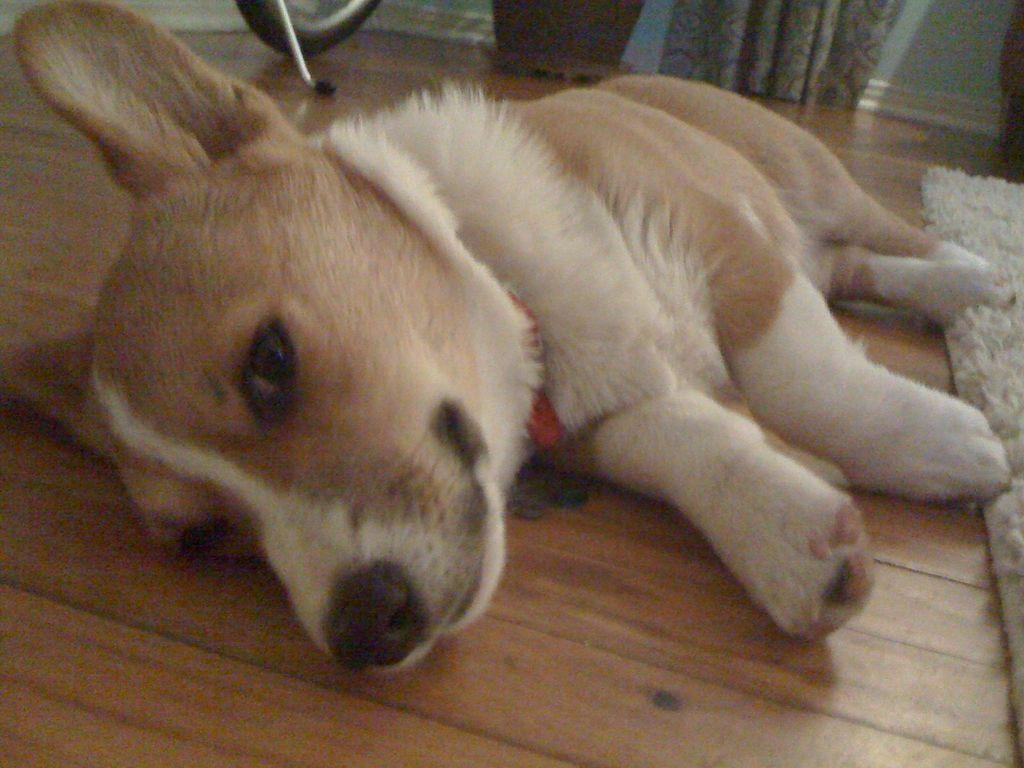What type of animal is present in the image? There is a dog in the image. What is the dog doing in the image? The dog is laying on the floor. What type of flooring is visible in the image? There is a carpet in the image. What other elements can be seen in the image? There is a curtain in the image. What accessory is the dog wearing? The dog has a locket around its neck. What colors can be seen on the dog? The dog's color is white and Brown. How many cats are sitting on the roof in the image? There are no cats or roof present in the image; it features a dog laying on a carpeted floor with a curtain in the background. 